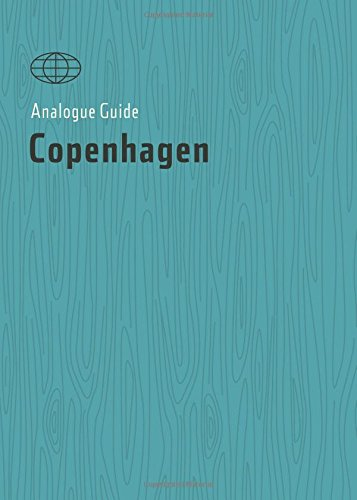Can you describe the aesthetic design or layout of the book? The book features a minimalist and clean design, using a calming blue tone throughout. The layout is user-friendly, ensuring that information is easily accessible. 